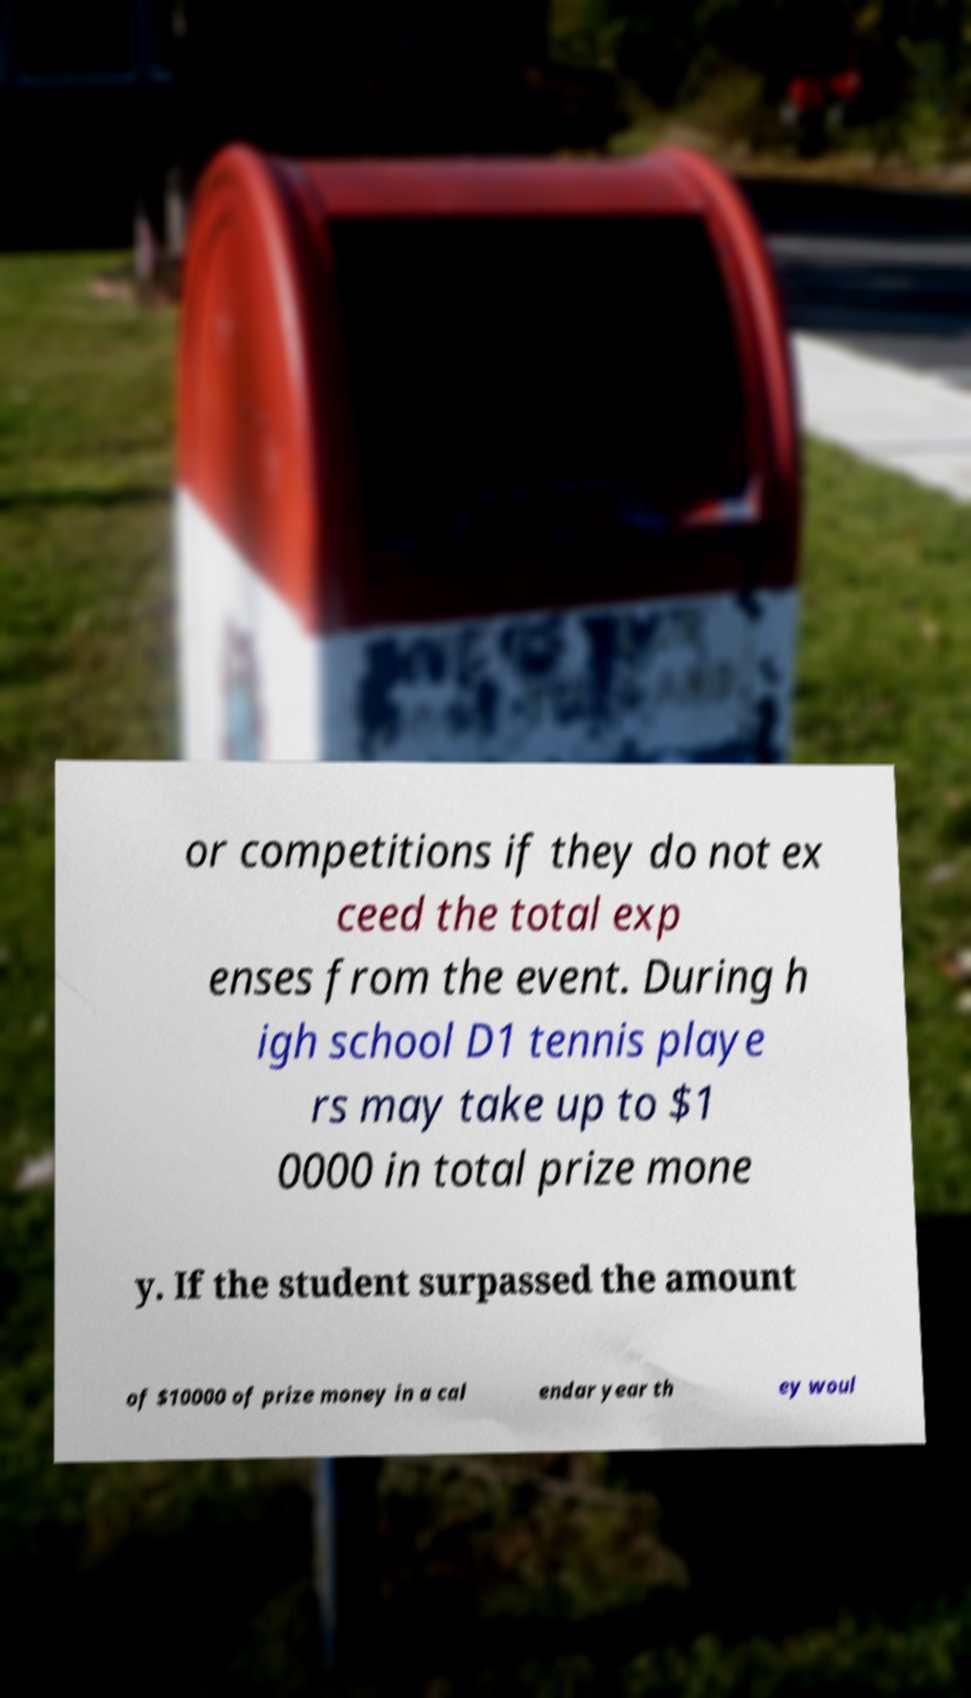Can you read and provide the text displayed in the image?This photo seems to have some interesting text. Can you extract and type it out for me? or competitions if they do not ex ceed the total exp enses from the event. During h igh school D1 tennis playe rs may take up to $1 0000 in total prize mone y. If the student surpassed the amount of $10000 of prize money in a cal endar year th ey woul 